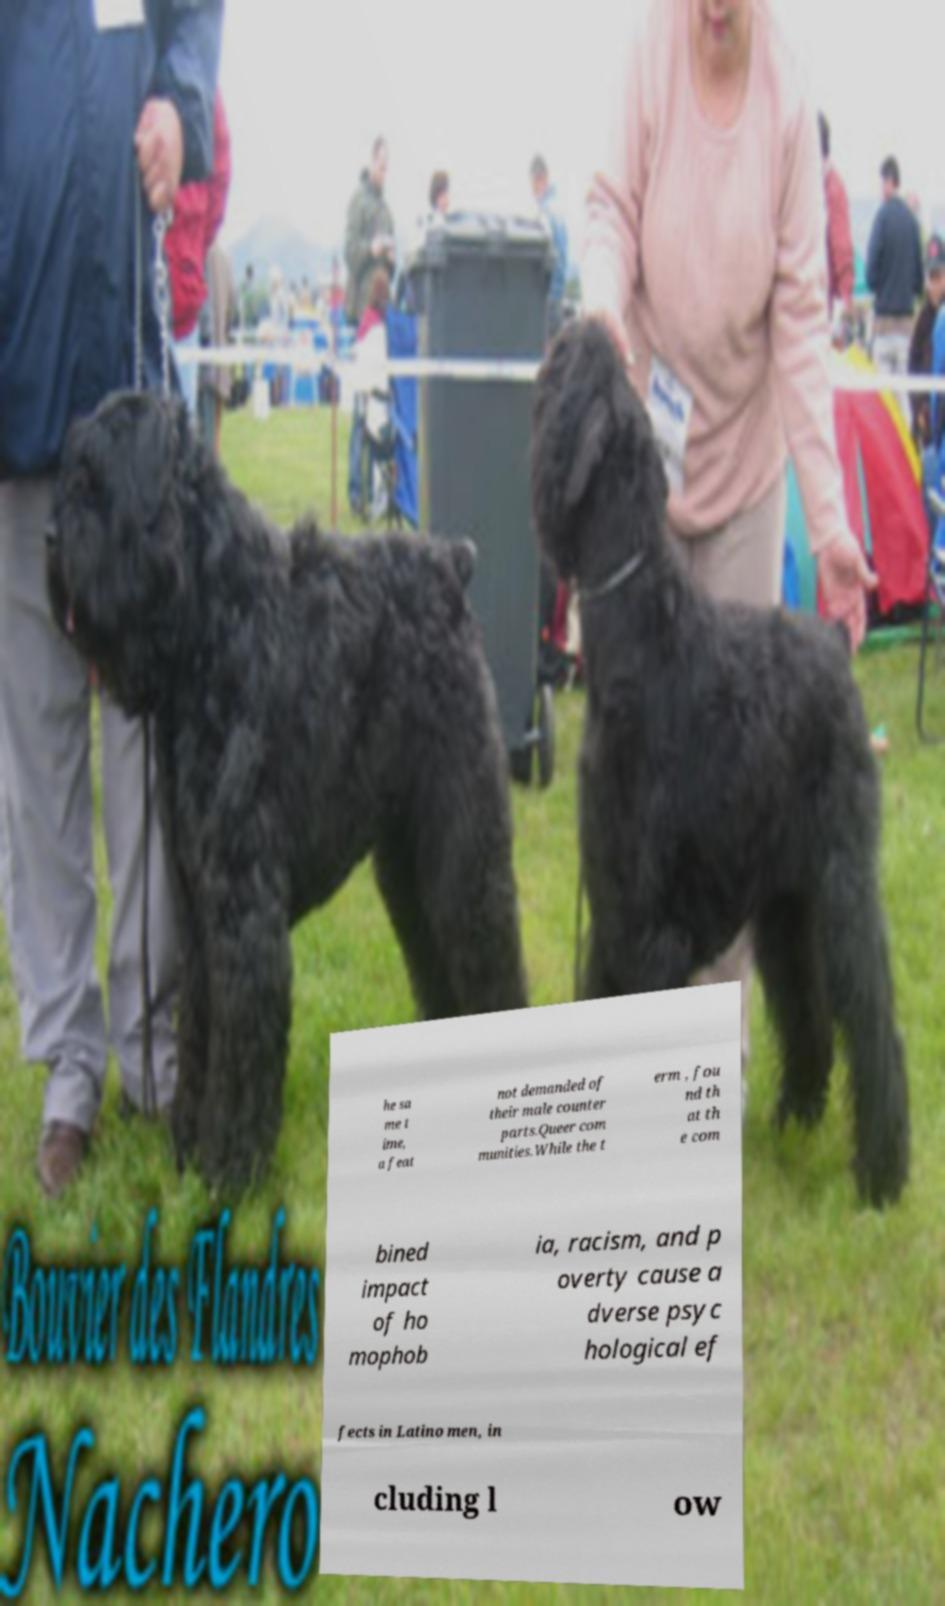There's text embedded in this image that I need extracted. Can you transcribe it verbatim? he sa me t ime, a feat not demanded of their male counter parts.Queer com munities.While the t erm , fou nd th at th e com bined impact of ho mophob ia, racism, and p overty cause a dverse psyc hological ef fects in Latino men, in cluding l ow 